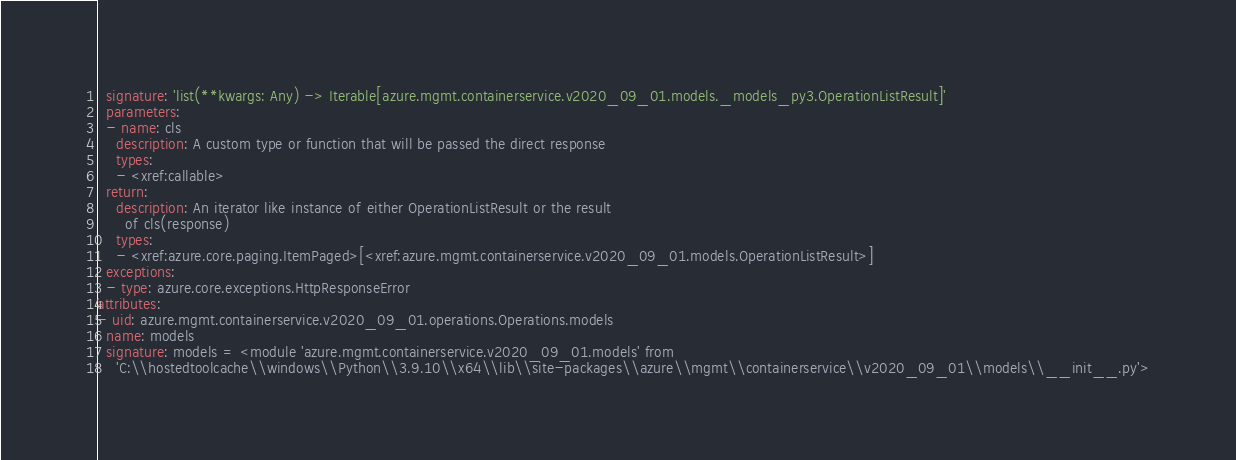<code> <loc_0><loc_0><loc_500><loc_500><_YAML_>  signature: 'list(**kwargs: Any) -> Iterable[azure.mgmt.containerservice.v2020_09_01.models._models_py3.OperationListResult]'
  parameters:
  - name: cls
    description: A custom type or function that will be passed the direct response
    types:
    - <xref:callable>
  return:
    description: An iterator like instance of either OperationListResult or the result
      of cls(response)
    types:
    - <xref:azure.core.paging.ItemPaged>[<xref:azure.mgmt.containerservice.v2020_09_01.models.OperationListResult>]
  exceptions:
  - type: azure.core.exceptions.HttpResponseError
attributes:
- uid: azure.mgmt.containerservice.v2020_09_01.operations.Operations.models
  name: models
  signature: models = <module 'azure.mgmt.containerservice.v2020_09_01.models' from
    'C:\\hostedtoolcache\\windows\\Python\\3.9.10\\x64\\lib\\site-packages\\azure\\mgmt\\containerservice\\v2020_09_01\\models\\__init__.py'>
</code> 